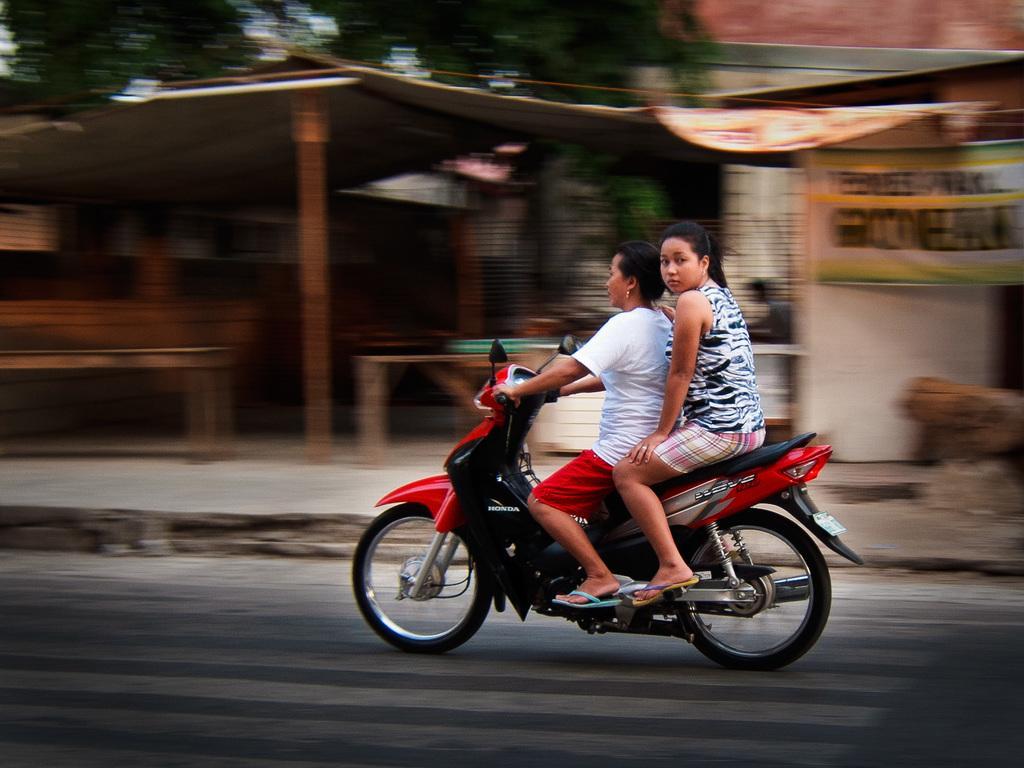How would you summarize this image in a sentence or two? In this picture two women are riding a bike and in the background we observe a poster attached to the building and there is a small house. 